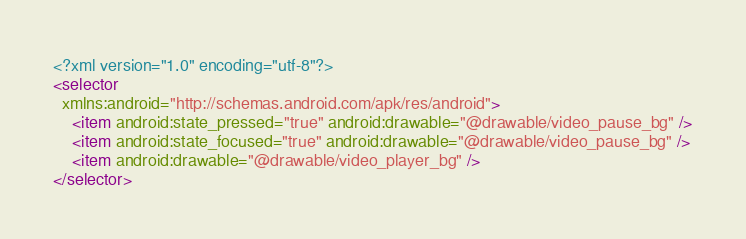Convert code to text. <code><loc_0><loc_0><loc_500><loc_500><_XML_><?xml version="1.0" encoding="utf-8"?>
<selector
  xmlns:android="http://schemas.android.com/apk/res/android">
    <item android:state_pressed="true" android:drawable="@drawable/video_pause_bg" />
    <item android:state_focused="true" android:drawable="@drawable/video_pause_bg" />
    <item android:drawable="@drawable/video_player_bg" />
</selector></code> 